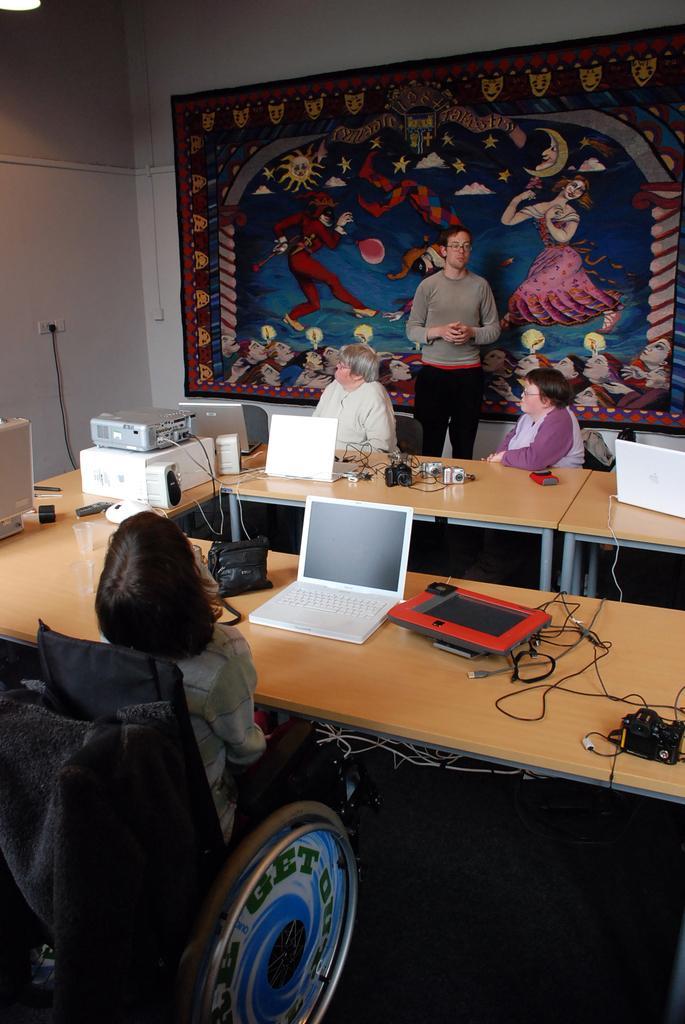Can you describe this image briefly? In this image I can see four people. Among them three people are sitting in-front of the table and one person is standing. On the table there is a laptop and some of the objects. In the background there is a banner to the wall. 